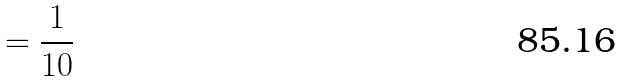<formula> <loc_0><loc_0><loc_500><loc_500>= \frac { 1 } { 1 0 }</formula> 